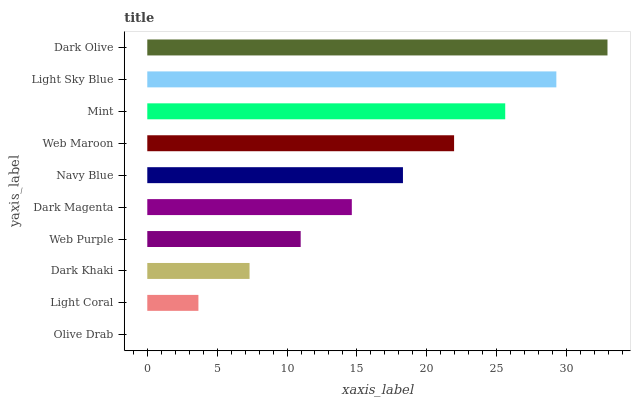Is Olive Drab the minimum?
Answer yes or no. Yes. Is Dark Olive the maximum?
Answer yes or no. Yes. Is Light Coral the minimum?
Answer yes or no. No. Is Light Coral the maximum?
Answer yes or no. No. Is Light Coral greater than Olive Drab?
Answer yes or no. Yes. Is Olive Drab less than Light Coral?
Answer yes or no. Yes. Is Olive Drab greater than Light Coral?
Answer yes or no. No. Is Light Coral less than Olive Drab?
Answer yes or no. No. Is Navy Blue the high median?
Answer yes or no. Yes. Is Dark Magenta the low median?
Answer yes or no. Yes. Is Mint the high median?
Answer yes or no. No. Is Navy Blue the low median?
Answer yes or no. No. 